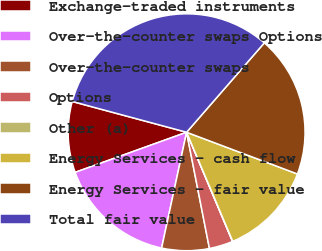Convert chart. <chart><loc_0><loc_0><loc_500><loc_500><pie_chart><fcel>Exchange-traded instruments<fcel>Over-the-counter swaps Options<fcel>Over-the-counter swaps<fcel>Options<fcel>Other (a)<fcel>Energy Services - cash flow<fcel>Energy Services - fair value<fcel>Total fair value<nl><fcel>9.68%<fcel>16.12%<fcel>6.47%<fcel>3.25%<fcel>0.03%<fcel>12.9%<fcel>19.34%<fcel>32.21%<nl></chart> 